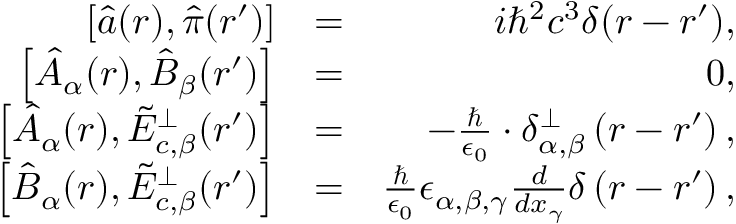Convert formula to latex. <formula><loc_0><loc_0><loc_500><loc_500>\begin{array} { r l r } { \left [ \hat { a } ( \boldsymbol r ) , \hat { \pi } ( \boldsymbol r ^ { \prime } ) \right ] } & { = } & { i \hbar { ^ } { 2 } c ^ { 3 } \delta ( \boldsymbol r - \boldsymbol r ^ { \prime } ) , } \\ { \left [ \hat { A } _ { \alpha } ( \boldsymbol r ) , \hat { B } _ { \beta } ( \boldsymbol r ^ { \prime } ) \right ] } & { = } & { 0 , } \\ { \left [ \hat { A } _ { \alpha } ( \boldsymbol r ) , \tilde { E } _ { c , \beta } ^ { \perp } ( \boldsymbol r ^ { \prime } ) \right ] } & { = } & { - \frac { } { \epsilon _ { 0 } } \cdot \delta _ { \alpha , \beta } ^ { \perp } \left ( \boldsymbol r - \boldsymbol r ^ { \prime } \right ) , } \\ { \left [ \hat { B } _ { \alpha } ( \boldsymbol r ) , \tilde { E } _ { c , \beta } ^ { \perp } ( \boldsymbol r ^ { \prime } ) \right ] } & { = } & { \frac { } { \epsilon _ { 0 } } \epsilon _ { \alpha , \beta , \gamma } \frac { d } { d x _ { \gamma } } \delta \left ( \boldsymbol r - \boldsymbol r ^ { \prime } \right ) , } \end{array}</formula> 